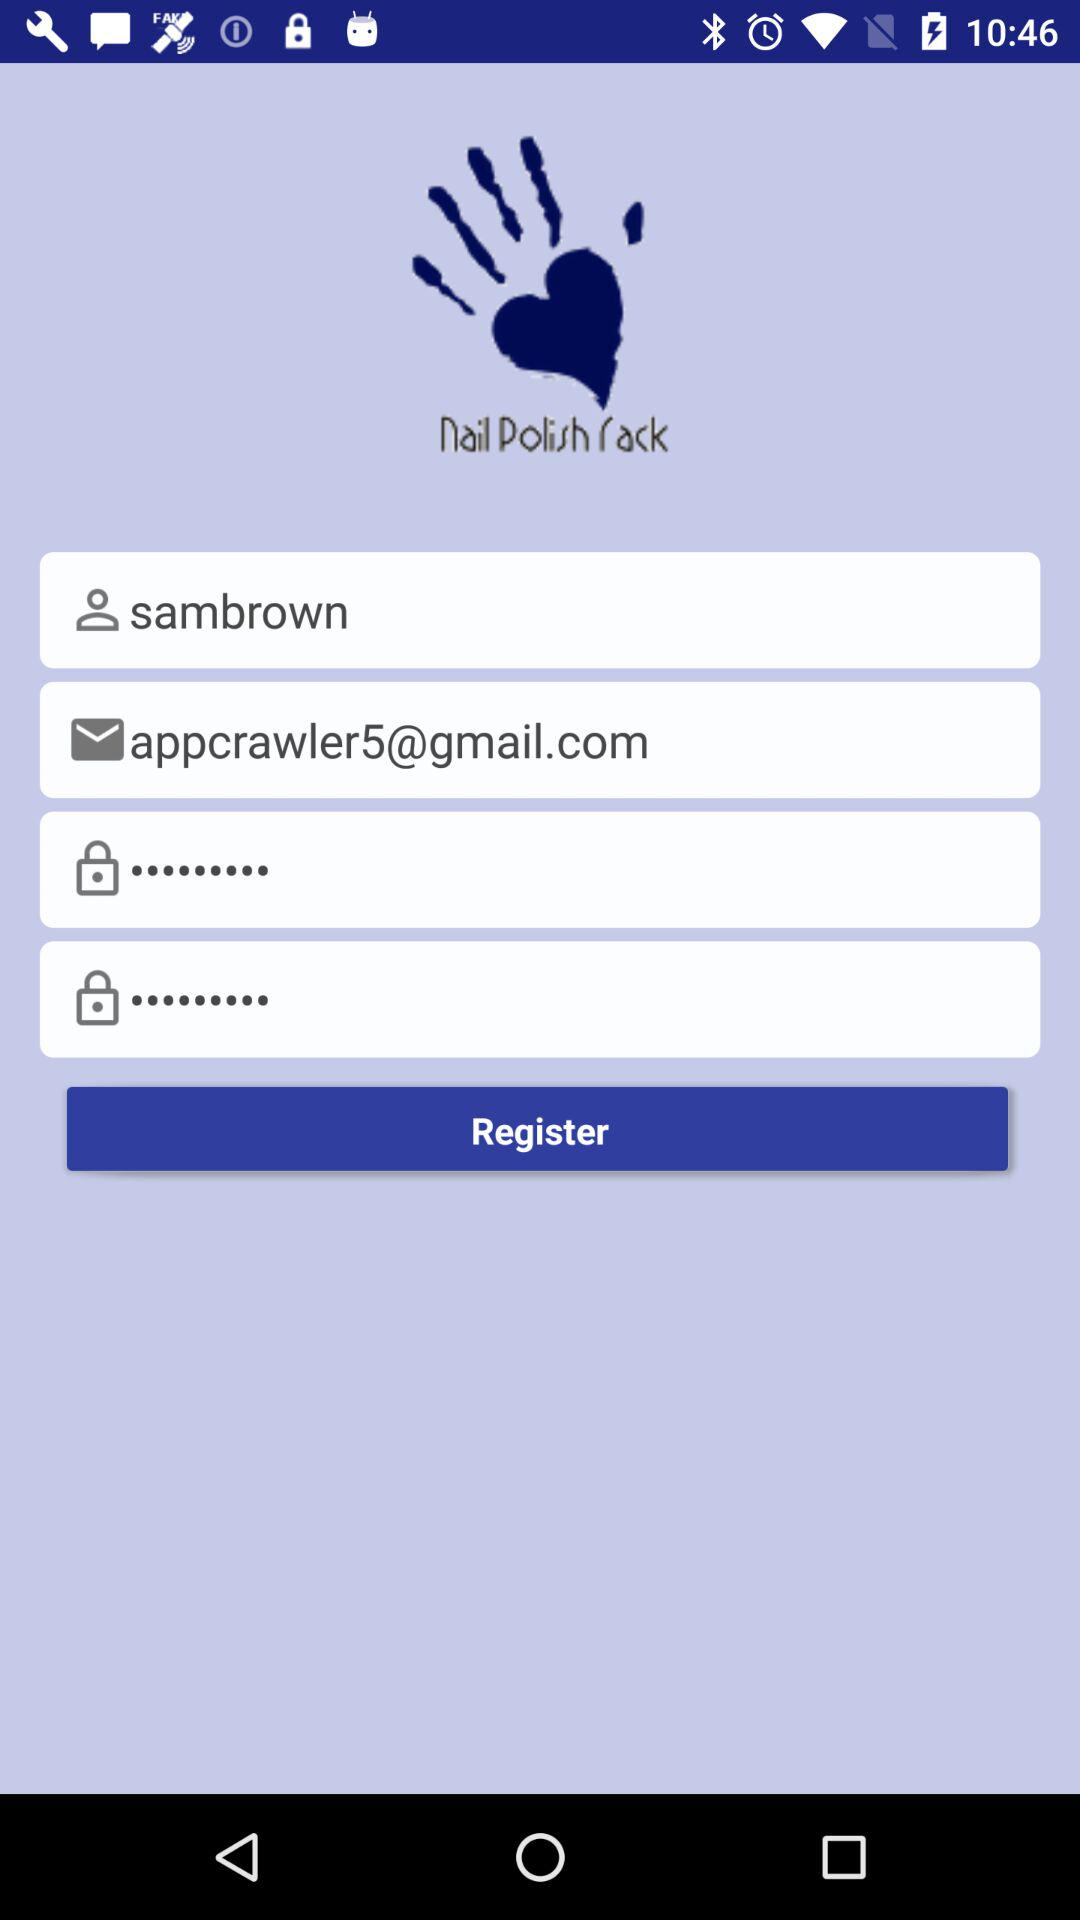What is the email address? The email address is appcrawler5@gmail.com. 